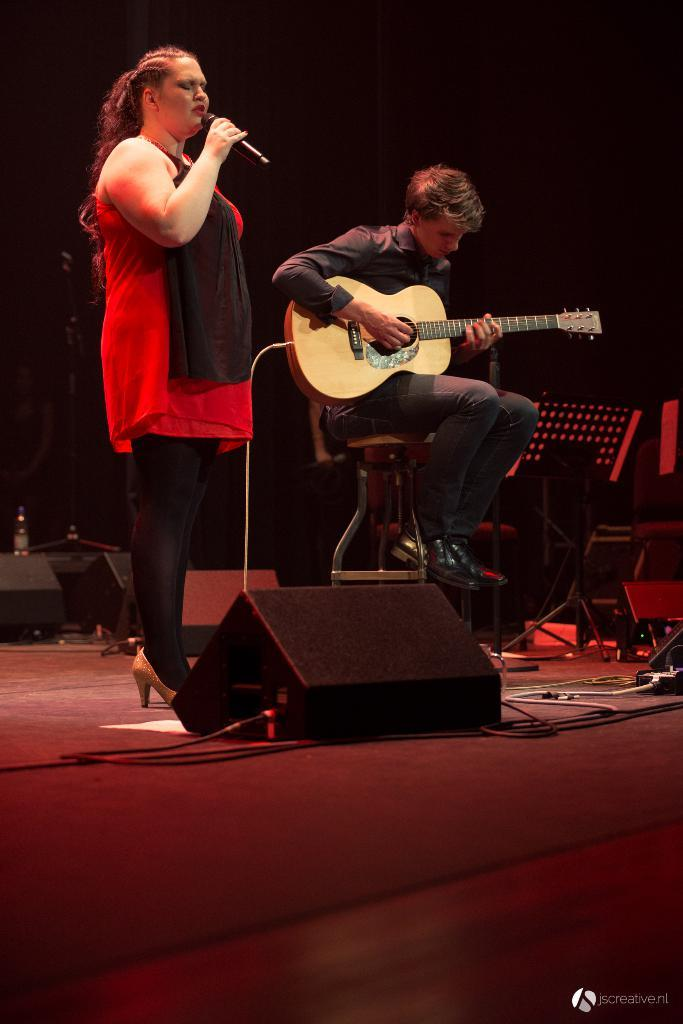What is the person on the left side of the image doing? The person on the left is singing. What object is the person on the left using while singing? The person on the left is in front of a microphone. What is the person on the right side of the image doing? The person on the right is playing a guitar. What type of wire is being pulled by the person on the left in the image? There is no wire being pulled by the person on the left in the image; they are singing in front of a microphone. 